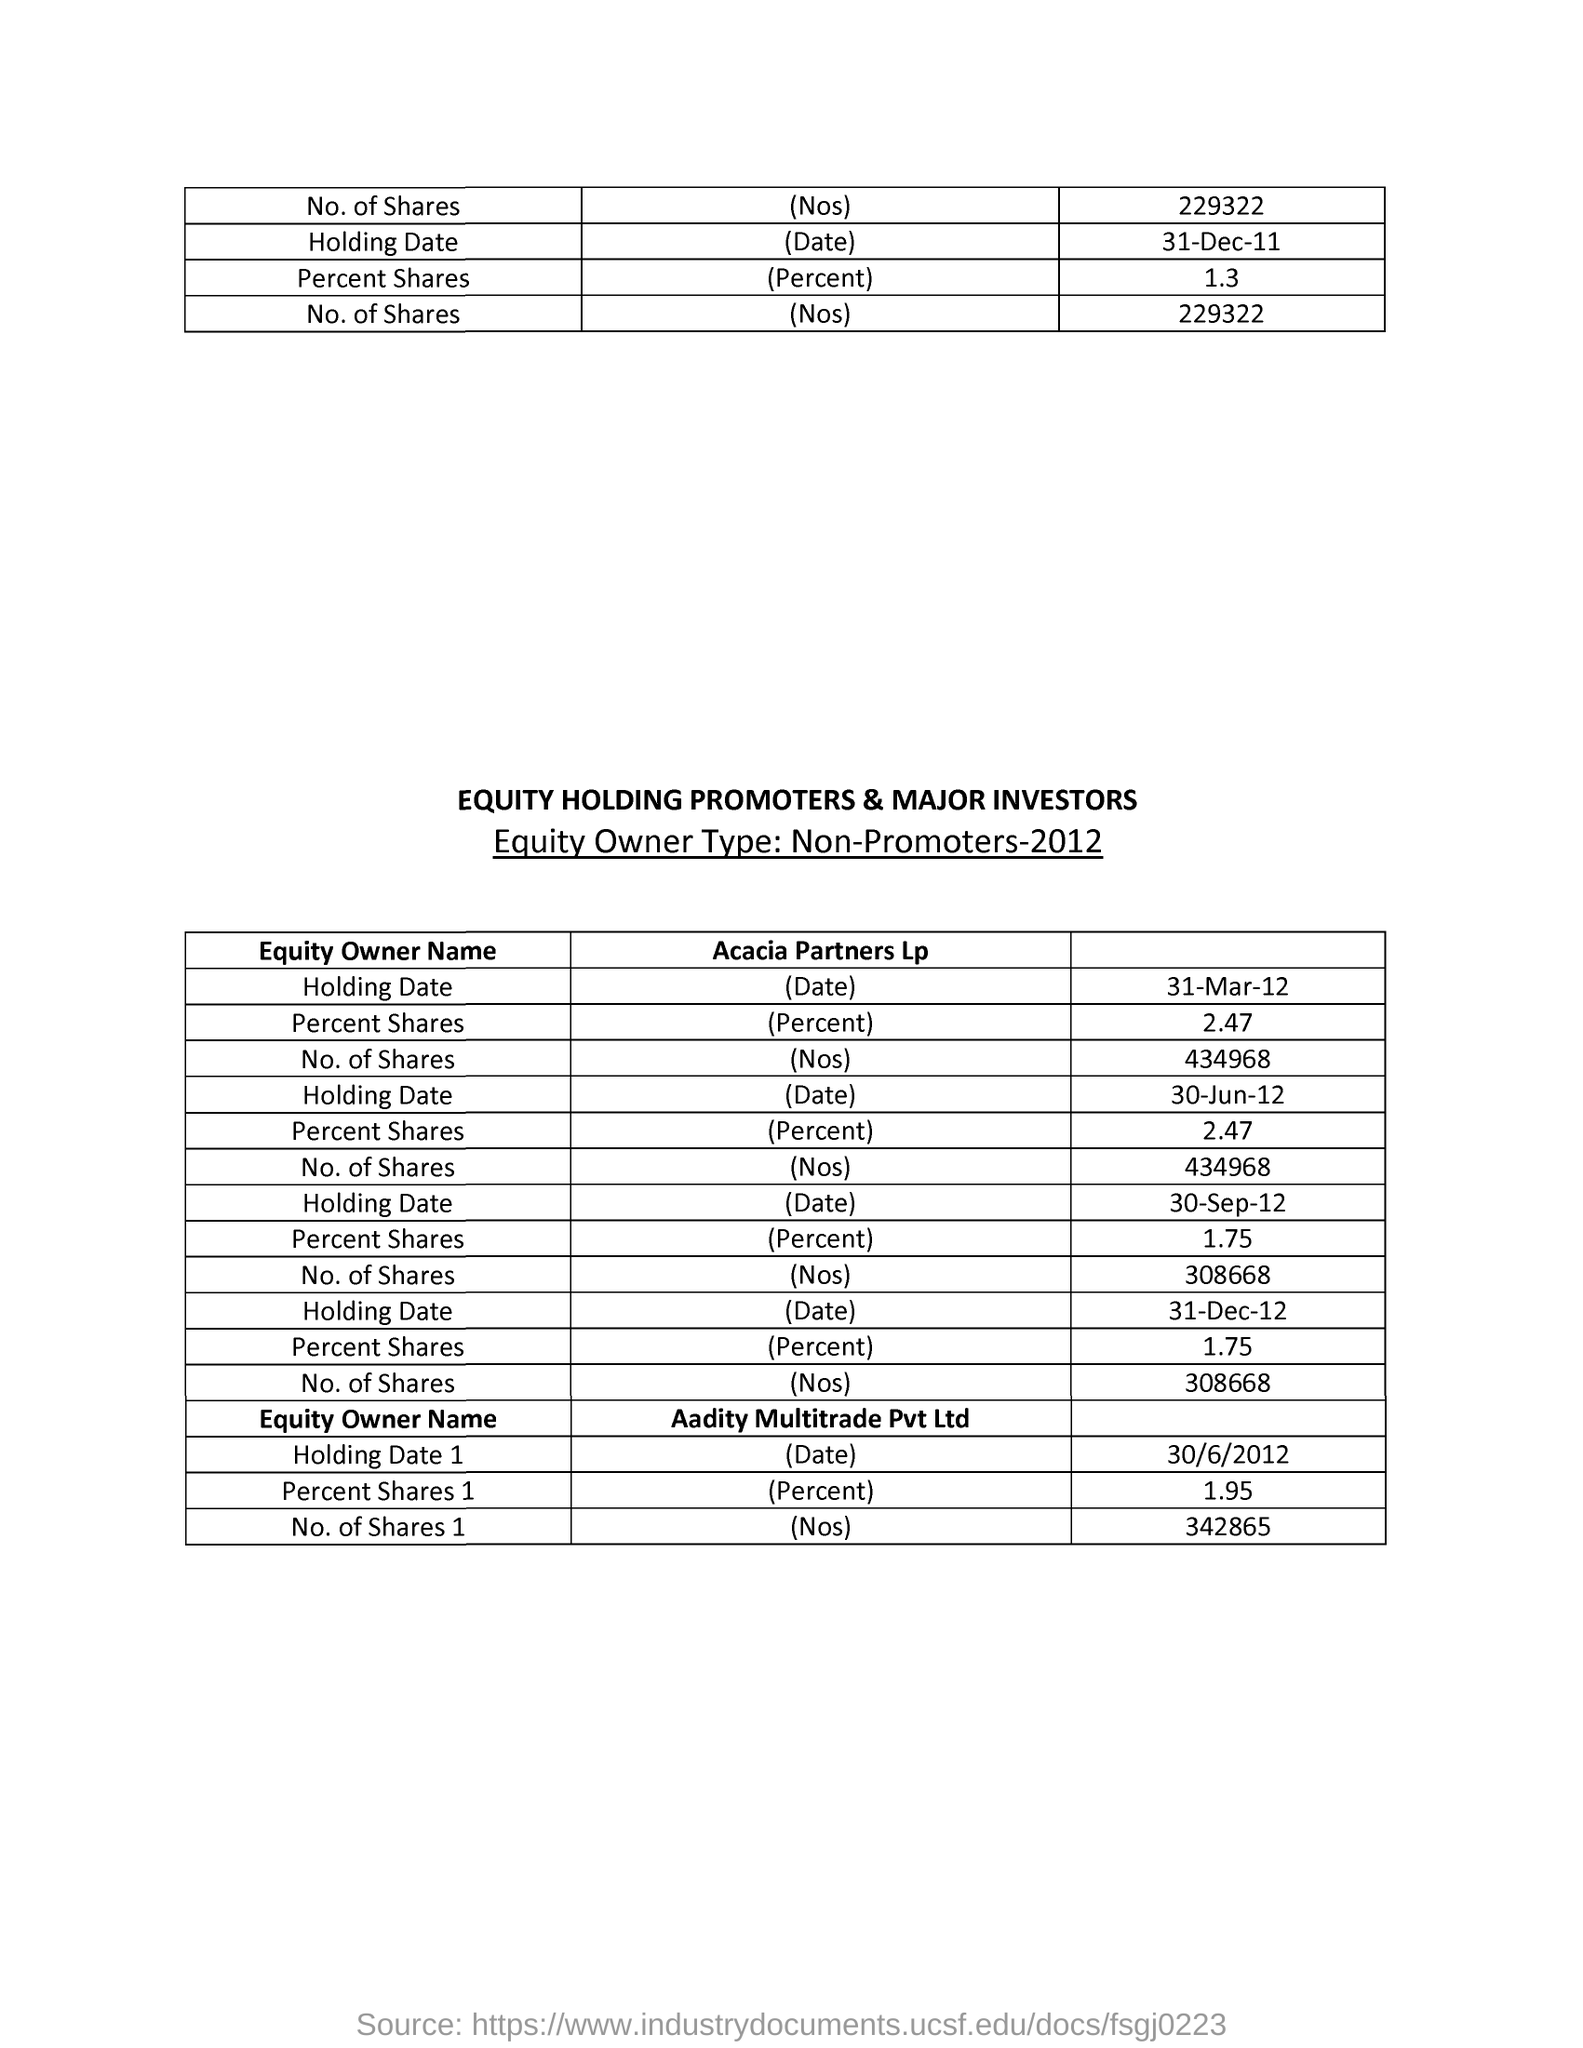Draw attention to some important aspects in this diagram. The Holding Date mentioned in the first table is December 31, 2011. The heading of the first column in the second table is "Equity Owner Name. The table provides details of the equity owner type, "Non-Promoters," for the year 2012. The "Holding Date 1" mentioned in the table is June 30, 2012. The heading of the table, written in capital letters and highlighted, is "Equity Holding Promoters & Major Investors. 